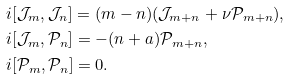Convert formula to latex. <formula><loc_0><loc_0><loc_500><loc_500>& i [ \mathcal { J } _ { m } , \mathcal { J } _ { n } ] = ( m - n ) ( \mathcal { J } _ { m + n } + \nu \mathcal { P } _ { m + n } ) , \\ & i [ \mathcal { J } _ { m } , \mathcal { P } _ { n } ] = - ( n + a ) \mathcal { P } _ { m + n } , \\ & i [ \mathcal { P } _ { m } , \mathcal { P } _ { n } ] = 0 .</formula> 